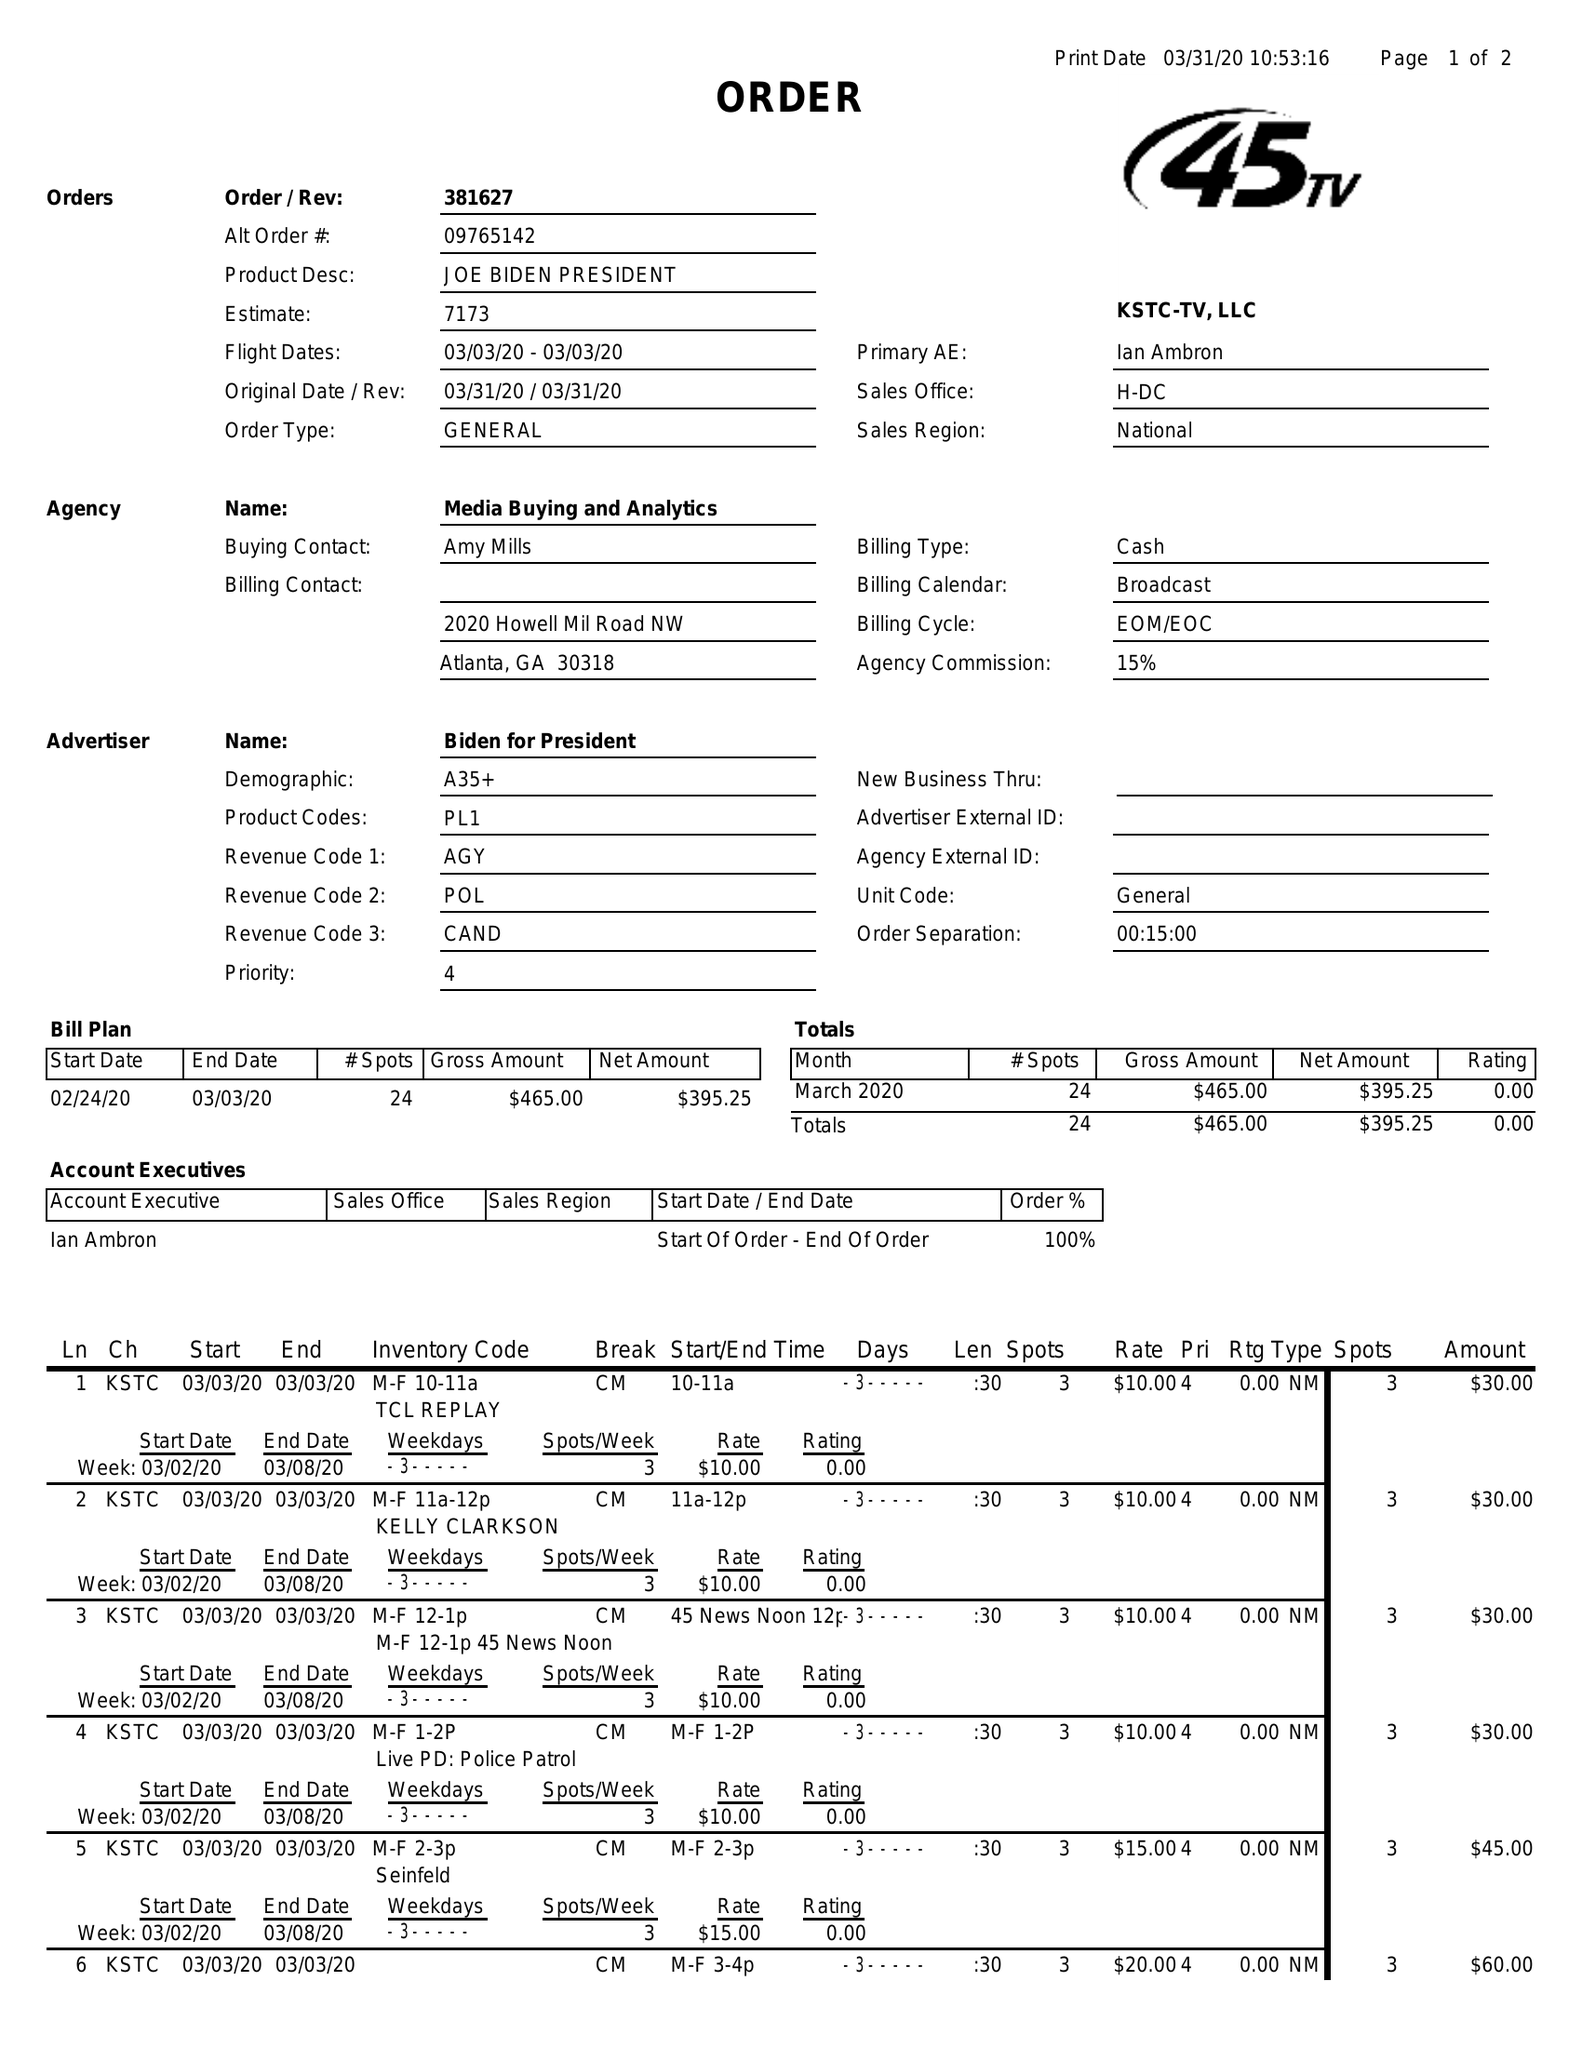What is the value for the flight_from?
Answer the question using a single word or phrase. 03/03/20 